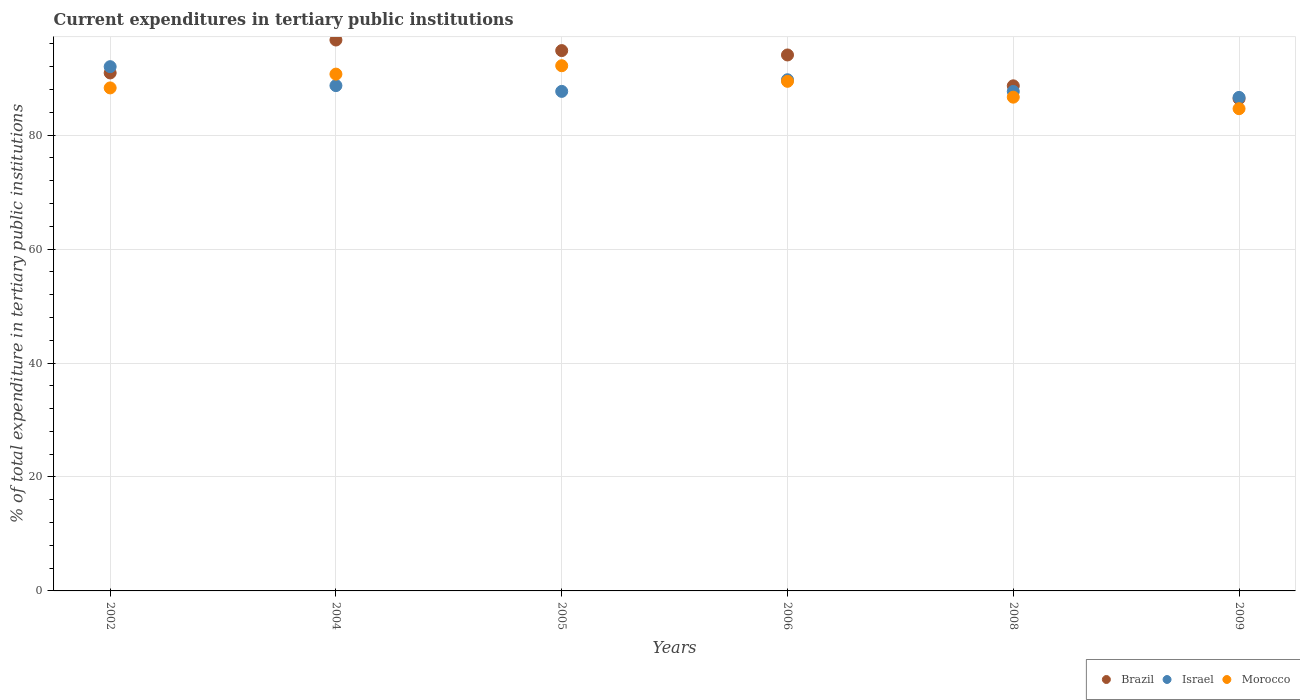How many different coloured dotlines are there?
Offer a terse response. 3. Is the number of dotlines equal to the number of legend labels?
Your answer should be very brief. Yes. What is the current expenditures in tertiary public institutions in Israel in 2002?
Provide a short and direct response. 92.02. Across all years, what is the maximum current expenditures in tertiary public institutions in Brazil?
Ensure brevity in your answer.  96.7. Across all years, what is the minimum current expenditures in tertiary public institutions in Israel?
Your answer should be compact. 86.62. In which year was the current expenditures in tertiary public institutions in Israel maximum?
Provide a succinct answer. 2002. What is the total current expenditures in tertiary public institutions in Morocco in the graph?
Provide a short and direct response. 531.93. What is the difference between the current expenditures in tertiary public institutions in Brazil in 2002 and that in 2005?
Ensure brevity in your answer.  -3.92. What is the difference between the current expenditures in tertiary public institutions in Israel in 2006 and the current expenditures in tertiary public institutions in Brazil in 2008?
Offer a very short reply. 1.07. What is the average current expenditures in tertiary public institutions in Morocco per year?
Provide a succinct answer. 88.65. In the year 2009, what is the difference between the current expenditures in tertiary public institutions in Israel and current expenditures in tertiary public institutions in Morocco?
Offer a terse response. 1.98. What is the ratio of the current expenditures in tertiary public institutions in Israel in 2005 to that in 2006?
Your answer should be compact. 0.98. Is the current expenditures in tertiary public institutions in Brazil in 2002 less than that in 2004?
Keep it short and to the point. Yes. Is the difference between the current expenditures in tertiary public institutions in Israel in 2004 and 2008 greater than the difference between the current expenditures in tertiary public institutions in Morocco in 2004 and 2008?
Provide a succinct answer. No. What is the difference between the highest and the second highest current expenditures in tertiary public institutions in Israel?
Your answer should be compact. 2.3. What is the difference between the highest and the lowest current expenditures in tertiary public institutions in Brazil?
Keep it short and to the point. 10.31. Is the current expenditures in tertiary public institutions in Morocco strictly greater than the current expenditures in tertiary public institutions in Brazil over the years?
Your response must be concise. No. Is the current expenditures in tertiary public institutions in Israel strictly less than the current expenditures in tertiary public institutions in Brazil over the years?
Ensure brevity in your answer.  No. What is the difference between two consecutive major ticks on the Y-axis?
Offer a terse response. 20. Does the graph contain any zero values?
Keep it short and to the point. No. Does the graph contain grids?
Your answer should be compact. Yes. How many legend labels are there?
Your answer should be compact. 3. What is the title of the graph?
Make the answer very short. Current expenditures in tertiary public institutions. What is the label or title of the Y-axis?
Your answer should be compact. % of total expenditure in tertiary public institutions. What is the % of total expenditure in tertiary public institutions in Brazil in 2002?
Your answer should be very brief. 90.92. What is the % of total expenditure in tertiary public institutions in Israel in 2002?
Give a very brief answer. 92.02. What is the % of total expenditure in tertiary public institutions in Morocco in 2002?
Give a very brief answer. 88.29. What is the % of total expenditure in tertiary public institutions in Brazil in 2004?
Your answer should be very brief. 96.7. What is the % of total expenditure in tertiary public institutions of Israel in 2004?
Your answer should be compact. 88.69. What is the % of total expenditure in tertiary public institutions in Morocco in 2004?
Give a very brief answer. 90.71. What is the % of total expenditure in tertiary public institutions in Brazil in 2005?
Keep it short and to the point. 94.84. What is the % of total expenditure in tertiary public institutions of Israel in 2005?
Offer a terse response. 87.68. What is the % of total expenditure in tertiary public institutions in Morocco in 2005?
Make the answer very short. 92.18. What is the % of total expenditure in tertiary public institutions in Brazil in 2006?
Offer a very short reply. 94.07. What is the % of total expenditure in tertiary public institutions in Israel in 2006?
Provide a succinct answer. 89.72. What is the % of total expenditure in tertiary public institutions of Morocco in 2006?
Provide a succinct answer. 89.45. What is the % of total expenditure in tertiary public institutions of Brazil in 2008?
Offer a very short reply. 88.65. What is the % of total expenditure in tertiary public institutions of Israel in 2008?
Offer a terse response. 87.67. What is the % of total expenditure in tertiary public institutions in Morocco in 2008?
Your answer should be compact. 86.66. What is the % of total expenditure in tertiary public institutions in Brazil in 2009?
Provide a short and direct response. 86.39. What is the % of total expenditure in tertiary public institutions in Israel in 2009?
Give a very brief answer. 86.62. What is the % of total expenditure in tertiary public institutions of Morocco in 2009?
Make the answer very short. 84.64. Across all years, what is the maximum % of total expenditure in tertiary public institutions in Brazil?
Provide a short and direct response. 96.7. Across all years, what is the maximum % of total expenditure in tertiary public institutions of Israel?
Your answer should be compact. 92.02. Across all years, what is the maximum % of total expenditure in tertiary public institutions in Morocco?
Ensure brevity in your answer.  92.18. Across all years, what is the minimum % of total expenditure in tertiary public institutions of Brazil?
Your answer should be very brief. 86.39. Across all years, what is the minimum % of total expenditure in tertiary public institutions of Israel?
Give a very brief answer. 86.62. Across all years, what is the minimum % of total expenditure in tertiary public institutions of Morocco?
Your answer should be very brief. 84.64. What is the total % of total expenditure in tertiary public institutions of Brazil in the graph?
Offer a terse response. 551.57. What is the total % of total expenditure in tertiary public institutions of Israel in the graph?
Provide a short and direct response. 532.39. What is the total % of total expenditure in tertiary public institutions of Morocco in the graph?
Your answer should be very brief. 531.93. What is the difference between the % of total expenditure in tertiary public institutions of Brazil in 2002 and that in 2004?
Give a very brief answer. -5.78. What is the difference between the % of total expenditure in tertiary public institutions in Israel in 2002 and that in 2004?
Make the answer very short. 3.33. What is the difference between the % of total expenditure in tertiary public institutions in Morocco in 2002 and that in 2004?
Your response must be concise. -2.42. What is the difference between the % of total expenditure in tertiary public institutions in Brazil in 2002 and that in 2005?
Your answer should be very brief. -3.92. What is the difference between the % of total expenditure in tertiary public institutions in Israel in 2002 and that in 2005?
Your answer should be very brief. 4.34. What is the difference between the % of total expenditure in tertiary public institutions of Morocco in 2002 and that in 2005?
Offer a terse response. -3.89. What is the difference between the % of total expenditure in tertiary public institutions of Brazil in 2002 and that in 2006?
Your answer should be very brief. -3.16. What is the difference between the % of total expenditure in tertiary public institutions of Israel in 2002 and that in 2006?
Offer a terse response. 2.3. What is the difference between the % of total expenditure in tertiary public institutions in Morocco in 2002 and that in 2006?
Give a very brief answer. -1.16. What is the difference between the % of total expenditure in tertiary public institutions in Brazil in 2002 and that in 2008?
Make the answer very short. 2.26. What is the difference between the % of total expenditure in tertiary public institutions in Israel in 2002 and that in 2008?
Provide a short and direct response. 4.35. What is the difference between the % of total expenditure in tertiary public institutions of Morocco in 2002 and that in 2008?
Your answer should be very brief. 1.63. What is the difference between the % of total expenditure in tertiary public institutions of Brazil in 2002 and that in 2009?
Your answer should be very brief. 4.53. What is the difference between the % of total expenditure in tertiary public institutions in Israel in 2002 and that in 2009?
Your answer should be very brief. 5.39. What is the difference between the % of total expenditure in tertiary public institutions in Morocco in 2002 and that in 2009?
Give a very brief answer. 3.65. What is the difference between the % of total expenditure in tertiary public institutions in Brazil in 2004 and that in 2005?
Your answer should be very brief. 1.86. What is the difference between the % of total expenditure in tertiary public institutions in Israel in 2004 and that in 2005?
Offer a terse response. 1.01. What is the difference between the % of total expenditure in tertiary public institutions of Morocco in 2004 and that in 2005?
Offer a terse response. -1.47. What is the difference between the % of total expenditure in tertiary public institutions of Brazil in 2004 and that in 2006?
Offer a terse response. 2.63. What is the difference between the % of total expenditure in tertiary public institutions in Israel in 2004 and that in 2006?
Your answer should be very brief. -1.03. What is the difference between the % of total expenditure in tertiary public institutions of Morocco in 2004 and that in 2006?
Ensure brevity in your answer.  1.26. What is the difference between the % of total expenditure in tertiary public institutions of Brazil in 2004 and that in 2008?
Offer a very short reply. 8.04. What is the difference between the % of total expenditure in tertiary public institutions in Israel in 2004 and that in 2008?
Make the answer very short. 1.02. What is the difference between the % of total expenditure in tertiary public institutions of Morocco in 2004 and that in 2008?
Give a very brief answer. 4.05. What is the difference between the % of total expenditure in tertiary public institutions in Brazil in 2004 and that in 2009?
Offer a very short reply. 10.31. What is the difference between the % of total expenditure in tertiary public institutions in Israel in 2004 and that in 2009?
Your response must be concise. 2.07. What is the difference between the % of total expenditure in tertiary public institutions in Morocco in 2004 and that in 2009?
Keep it short and to the point. 6.07. What is the difference between the % of total expenditure in tertiary public institutions in Brazil in 2005 and that in 2006?
Provide a short and direct response. 0.77. What is the difference between the % of total expenditure in tertiary public institutions of Israel in 2005 and that in 2006?
Offer a terse response. -2.04. What is the difference between the % of total expenditure in tertiary public institutions in Morocco in 2005 and that in 2006?
Your answer should be compact. 2.74. What is the difference between the % of total expenditure in tertiary public institutions in Brazil in 2005 and that in 2008?
Provide a succinct answer. 6.18. What is the difference between the % of total expenditure in tertiary public institutions of Israel in 2005 and that in 2008?
Keep it short and to the point. 0.01. What is the difference between the % of total expenditure in tertiary public institutions in Morocco in 2005 and that in 2008?
Provide a short and direct response. 5.52. What is the difference between the % of total expenditure in tertiary public institutions of Brazil in 2005 and that in 2009?
Provide a succinct answer. 8.45. What is the difference between the % of total expenditure in tertiary public institutions in Israel in 2005 and that in 2009?
Offer a very short reply. 1.06. What is the difference between the % of total expenditure in tertiary public institutions of Morocco in 2005 and that in 2009?
Offer a terse response. 7.54. What is the difference between the % of total expenditure in tertiary public institutions in Brazil in 2006 and that in 2008?
Give a very brief answer. 5.42. What is the difference between the % of total expenditure in tertiary public institutions in Israel in 2006 and that in 2008?
Provide a short and direct response. 2.05. What is the difference between the % of total expenditure in tertiary public institutions of Morocco in 2006 and that in 2008?
Your answer should be compact. 2.78. What is the difference between the % of total expenditure in tertiary public institutions of Brazil in 2006 and that in 2009?
Give a very brief answer. 7.68. What is the difference between the % of total expenditure in tertiary public institutions in Israel in 2006 and that in 2009?
Your answer should be very brief. 3.1. What is the difference between the % of total expenditure in tertiary public institutions in Morocco in 2006 and that in 2009?
Ensure brevity in your answer.  4.81. What is the difference between the % of total expenditure in tertiary public institutions of Brazil in 2008 and that in 2009?
Offer a very short reply. 2.27. What is the difference between the % of total expenditure in tertiary public institutions in Israel in 2008 and that in 2009?
Provide a succinct answer. 1.04. What is the difference between the % of total expenditure in tertiary public institutions in Morocco in 2008 and that in 2009?
Ensure brevity in your answer.  2.02. What is the difference between the % of total expenditure in tertiary public institutions of Brazil in 2002 and the % of total expenditure in tertiary public institutions of Israel in 2004?
Give a very brief answer. 2.23. What is the difference between the % of total expenditure in tertiary public institutions in Brazil in 2002 and the % of total expenditure in tertiary public institutions in Morocco in 2004?
Keep it short and to the point. 0.21. What is the difference between the % of total expenditure in tertiary public institutions of Israel in 2002 and the % of total expenditure in tertiary public institutions of Morocco in 2004?
Provide a succinct answer. 1.31. What is the difference between the % of total expenditure in tertiary public institutions in Brazil in 2002 and the % of total expenditure in tertiary public institutions in Israel in 2005?
Offer a very short reply. 3.24. What is the difference between the % of total expenditure in tertiary public institutions in Brazil in 2002 and the % of total expenditure in tertiary public institutions in Morocco in 2005?
Your response must be concise. -1.27. What is the difference between the % of total expenditure in tertiary public institutions in Israel in 2002 and the % of total expenditure in tertiary public institutions in Morocco in 2005?
Keep it short and to the point. -0.17. What is the difference between the % of total expenditure in tertiary public institutions of Brazil in 2002 and the % of total expenditure in tertiary public institutions of Israel in 2006?
Make the answer very short. 1.2. What is the difference between the % of total expenditure in tertiary public institutions of Brazil in 2002 and the % of total expenditure in tertiary public institutions of Morocco in 2006?
Offer a very short reply. 1.47. What is the difference between the % of total expenditure in tertiary public institutions of Israel in 2002 and the % of total expenditure in tertiary public institutions of Morocco in 2006?
Your answer should be very brief. 2.57. What is the difference between the % of total expenditure in tertiary public institutions in Brazil in 2002 and the % of total expenditure in tertiary public institutions in Israel in 2008?
Ensure brevity in your answer.  3.25. What is the difference between the % of total expenditure in tertiary public institutions of Brazil in 2002 and the % of total expenditure in tertiary public institutions of Morocco in 2008?
Your answer should be compact. 4.25. What is the difference between the % of total expenditure in tertiary public institutions in Israel in 2002 and the % of total expenditure in tertiary public institutions in Morocco in 2008?
Your answer should be very brief. 5.35. What is the difference between the % of total expenditure in tertiary public institutions of Brazil in 2002 and the % of total expenditure in tertiary public institutions of Israel in 2009?
Ensure brevity in your answer.  4.29. What is the difference between the % of total expenditure in tertiary public institutions in Brazil in 2002 and the % of total expenditure in tertiary public institutions in Morocco in 2009?
Your answer should be compact. 6.28. What is the difference between the % of total expenditure in tertiary public institutions of Israel in 2002 and the % of total expenditure in tertiary public institutions of Morocco in 2009?
Your answer should be very brief. 7.38. What is the difference between the % of total expenditure in tertiary public institutions of Brazil in 2004 and the % of total expenditure in tertiary public institutions of Israel in 2005?
Keep it short and to the point. 9.02. What is the difference between the % of total expenditure in tertiary public institutions of Brazil in 2004 and the % of total expenditure in tertiary public institutions of Morocco in 2005?
Your answer should be very brief. 4.51. What is the difference between the % of total expenditure in tertiary public institutions in Israel in 2004 and the % of total expenditure in tertiary public institutions in Morocco in 2005?
Make the answer very short. -3.49. What is the difference between the % of total expenditure in tertiary public institutions in Brazil in 2004 and the % of total expenditure in tertiary public institutions in Israel in 2006?
Provide a succinct answer. 6.98. What is the difference between the % of total expenditure in tertiary public institutions of Brazil in 2004 and the % of total expenditure in tertiary public institutions of Morocco in 2006?
Offer a terse response. 7.25. What is the difference between the % of total expenditure in tertiary public institutions in Israel in 2004 and the % of total expenditure in tertiary public institutions in Morocco in 2006?
Make the answer very short. -0.75. What is the difference between the % of total expenditure in tertiary public institutions in Brazil in 2004 and the % of total expenditure in tertiary public institutions in Israel in 2008?
Provide a short and direct response. 9.03. What is the difference between the % of total expenditure in tertiary public institutions in Brazil in 2004 and the % of total expenditure in tertiary public institutions in Morocco in 2008?
Provide a succinct answer. 10.03. What is the difference between the % of total expenditure in tertiary public institutions of Israel in 2004 and the % of total expenditure in tertiary public institutions of Morocco in 2008?
Your answer should be very brief. 2.03. What is the difference between the % of total expenditure in tertiary public institutions in Brazil in 2004 and the % of total expenditure in tertiary public institutions in Israel in 2009?
Offer a very short reply. 10.07. What is the difference between the % of total expenditure in tertiary public institutions in Brazil in 2004 and the % of total expenditure in tertiary public institutions in Morocco in 2009?
Offer a very short reply. 12.06. What is the difference between the % of total expenditure in tertiary public institutions of Israel in 2004 and the % of total expenditure in tertiary public institutions of Morocco in 2009?
Offer a very short reply. 4.05. What is the difference between the % of total expenditure in tertiary public institutions of Brazil in 2005 and the % of total expenditure in tertiary public institutions of Israel in 2006?
Make the answer very short. 5.12. What is the difference between the % of total expenditure in tertiary public institutions in Brazil in 2005 and the % of total expenditure in tertiary public institutions in Morocco in 2006?
Make the answer very short. 5.39. What is the difference between the % of total expenditure in tertiary public institutions in Israel in 2005 and the % of total expenditure in tertiary public institutions in Morocco in 2006?
Make the answer very short. -1.77. What is the difference between the % of total expenditure in tertiary public institutions in Brazil in 2005 and the % of total expenditure in tertiary public institutions in Israel in 2008?
Provide a short and direct response. 7.17. What is the difference between the % of total expenditure in tertiary public institutions of Brazil in 2005 and the % of total expenditure in tertiary public institutions of Morocco in 2008?
Provide a succinct answer. 8.18. What is the difference between the % of total expenditure in tertiary public institutions of Israel in 2005 and the % of total expenditure in tertiary public institutions of Morocco in 2008?
Provide a succinct answer. 1.02. What is the difference between the % of total expenditure in tertiary public institutions in Brazil in 2005 and the % of total expenditure in tertiary public institutions in Israel in 2009?
Provide a short and direct response. 8.22. What is the difference between the % of total expenditure in tertiary public institutions of Brazil in 2005 and the % of total expenditure in tertiary public institutions of Morocco in 2009?
Keep it short and to the point. 10.2. What is the difference between the % of total expenditure in tertiary public institutions of Israel in 2005 and the % of total expenditure in tertiary public institutions of Morocco in 2009?
Make the answer very short. 3.04. What is the difference between the % of total expenditure in tertiary public institutions of Brazil in 2006 and the % of total expenditure in tertiary public institutions of Israel in 2008?
Your response must be concise. 6.4. What is the difference between the % of total expenditure in tertiary public institutions in Brazil in 2006 and the % of total expenditure in tertiary public institutions in Morocco in 2008?
Your answer should be compact. 7.41. What is the difference between the % of total expenditure in tertiary public institutions of Israel in 2006 and the % of total expenditure in tertiary public institutions of Morocco in 2008?
Offer a terse response. 3.06. What is the difference between the % of total expenditure in tertiary public institutions in Brazil in 2006 and the % of total expenditure in tertiary public institutions in Israel in 2009?
Ensure brevity in your answer.  7.45. What is the difference between the % of total expenditure in tertiary public institutions in Brazil in 2006 and the % of total expenditure in tertiary public institutions in Morocco in 2009?
Give a very brief answer. 9.43. What is the difference between the % of total expenditure in tertiary public institutions in Israel in 2006 and the % of total expenditure in tertiary public institutions in Morocco in 2009?
Your answer should be very brief. 5.08. What is the difference between the % of total expenditure in tertiary public institutions in Brazil in 2008 and the % of total expenditure in tertiary public institutions in Israel in 2009?
Your answer should be very brief. 2.03. What is the difference between the % of total expenditure in tertiary public institutions in Brazil in 2008 and the % of total expenditure in tertiary public institutions in Morocco in 2009?
Offer a very short reply. 4.01. What is the difference between the % of total expenditure in tertiary public institutions of Israel in 2008 and the % of total expenditure in tertiary public institutions of Morocco in 2009?
Your response must be concise. 3.03. What is the average % of total expenditure in tertiary public institutions in Brazil per year?
Give a very brief answer. 91.93. What is the average % of total expenditure in tertiary public institutions in Israel per year?
Ensure brevity in your answer.  88.73. What is the average % of total expenditure in tertiary public institutions of Morocco per year?
Ensure brevity in your answer.  88.65. In the year 2002, what is the difference between the % of total expenditure in tertiary public institutions in Brazil and % of total expenditure in tertiary public institutions in Israel?
Your answer should be very brief. -1.1. In the year 2002, what is the difference between the % of total expenditure in tertiary public institutions in Brazil and % of total expenditure in tertiary public institutions in Morocco?
Your answer should be very brief. 2.63. In the year 2002, what is the difference between the % of total expenditure in tertiary public institutions in Israel and % of total expenditure in tertiary public institutions in Morocco?
Your answer should be compact. 3.73. In the year 2004, what is the difference between the % of total expenditure in tertiary public institutions in Brazil and % of total expenditure in tertiary public institutions in Israel?
Ensure brevity in your answer.  8.01. In the year 2004, what is the difference between the % of total expenditure in tertiary public institutions of Brazil and % of total expenditure in tertiary public institutions of Morocco?
Make the answer very short. 5.99. In the year 2004, what is the difference between the % of total expenditure in tertiary public institutions in Israel and % of total expenditure in tertiary public institutions in Morocco?
Ensure brevity in your answer.  -2.02. In the year 2005, what is the difference between the % of total expenditure in tertiary public institutions of Brazil and % of total expenditure in tertiary public institutions of Israel?
Provide a succinct answer. 7.16. In the year 2005, what is the difference between the % of total expenditure in tertiary public institutions of Brazil and % of total expenditure in tertiary public institutions of Morocco?
Offer a very short reply. 2.66. In the year 2005, what is the difference between the % of total expenditure in tertiary public institutions of Israel and % of total expenditure in tertiary public institutions of Morocco?
Offer a terse response. -4.5. In the year 2006, what is the difference between the % of total expenditure in tertiary public institutions in Brazil and % of total expenditure in tertiary public institutions in Israel?
Offer a very short reply. 4.35. In the year 2006, what is the difference between the % of total expenditure in tertiary public institutions in Brazil and % of total expenditure in tertiary public institutions in Morocco?
Offer a very short reply. 4.63. In the year 2006, what is the difference between the % of total expenditure in tertiary public institutions of Israel and % of total expenditure in tertiary public institutions of Morocco?
Your response must be concise. 0.27. In the year 2008, what is the difference between the % of total expenditure in tertiary public institutions of Brazil and % of total expenditure in tertiary public institutions of Israel?
Your response must be concise. 0.99. In the year 2008, what is the difference between the % of total expenditure in tertiary public institutions in Brazil and % of total expenditure in tertiary public institutions in Morocco?
Your response must be concise. 1.99. In the year 2008, what is the difference between the % of total expenditure in tertiary public institutions in Israel and % of total expenditure in tertiary public institutions in Morocco?
Give a very brief answer. 1. In the year 2009, what is the difference between the % of total expenditure in tertiary public institutions of Brazil and % of total expenditure in tertiary public institutions of Israel?
Offer a very short reply. -0.23. In the year 2009, what is the difference between the % of total expenditure in tertiary public institutions in Brazil and % of total expenditure in tertiary public institutions in Morocco?
Give a very brief answer. 1.75. In the year 2009, what is the difference between the % of total expenditure in tertiary public institutions in Israel and % of total expenditure in tertiary public institutions in Morocco?
Offer a terse response. 1.98. What is the ratio of the % of total expenditure in tertiary public institutions in Brazil in 2002 to that in 2004?
Offer a very short reply. 0.94. What is the ratio of the % of total expenditure in tertiary public institutions of Israel in 2002 to that in 2004?
Ensure brevity in your answer.  1.04. What is the ratio of the % of total expenditure in tertiary public institutions of Morocco in 2002 to that in 2004?
Give a very brief answer. 0.97. What is the ratio of the % of total expenditure in tertiary public institutions in Brazil in 2002 to that in 2005?
Provide a short and direct response. 0.96. What is the ratio of the % of total expenditure in tertiary public institutions in Israel in 2002 to that in 2005?
Provide a short and direct response. 1.05. What is the ratio of the % of total expenditure in tertiary public institutions of Morocco in 2002 to that in 2005?
Keep it short and to the point. 0.96. What is the ratio of the % of total expenditure in tertiary public institutions in Brazil in 2002 to that in 2006?
Offer a very short reply. 0.97. What is the ratio of the % of total expenditure in tertiary public institutions in Israel in 2002 to that in 2006?
Make the answer very short. 1.03. What is the ratio of the % of total expenditure in tertiary public institutions of Morocco in 2002 to that in 2006?
Your answer should be very brief. 0.99. What is the ratio of the % of total expenditure in tertiary public institutions of Brazil in 2002 to that in 2008?
Your answer should be very brief. 1.03. What is the ratio of the % of total expenditure in tertiary public institutions of Israel in 2002 to that in 2008?
Provide a short and direct response. 1.05. What is the ratio of the % of total expenditure in tertiary public institutions of Morocco in 2002 to that in 2008?
Your response must be concise. 1.02. What is the ratio of the % of total expenditure in tertiary public institutions in Brazil in 2002 to that in 2009?
Make the answer very short. 1.05. What is the ratio of the % of total expenditure in tertiary public institutions of Israel in 2002 to that in 2009?
Your answer should be compact. 1.06. What is the ratio of the % of total expenditure in tertiary public institutions in Morocco in 2002 to that in 2009?
Your response must be concise. 1.04. What is the ratio of the % of total expenditure in tertiary public institutions of Brazil in 2004 to that in 2005?
Ensure brevity in your answer.  1.02. What is the ratio of the % of total expenditure in tertiary public institutions in Israel in 2004 to that in 2005?
Your answer should be very brief. 1.01. What is the ratio of the % of total expenditure in tertiary public institutions in Morocco in 2004 to that in 2005?
Give a very brief answer. 0.98. What is the ratio of the % of total expenditure in tertiary public institutions of Brazil in 2004 to that in 2006?
Your answer should be very brief. 1.03. What is the ratio of the % of total expenditure in tertiary public institutions of Israel in 2004 to that in 2006?
Your response must be concise. 0.99. What is the ratio of the % of total expenditure in tertiary public institutions in Morocco in 2004 to that in 2006?
Your answer should be very brief. 1.01. What is the ratio of the % of total expenditure in tertiary public institutions in Brazil in 2004 to that in 2008?
Offer a very short reply. 1.09. What is the ratio of the % of total expenditure in tertiary public institutions in Israel in 2004 to that in 2008?
Provide a short and direct response. 1.01. What is the ratio of the % of total expenditure in tertiary public institutions in Morocco in 2004 to that in 2008?
Provide a succinct answer. 1.05. What is the ratio of the % of total expenditure in tertiary public institutions of Brazil in 2004 to that in 2009?
Give a very brief answer. 1.12. What is the ratio of the % of total expenditure in tertiary public institutions of Israel in 2004 to that in 2009?
Offer a terse response. 1.02. What is the ratio of the % of total expenditure in tertiary public institutions of Morocco in 2004 to that in 2009?
Offer a terse response. 1.07. What is the ratio of the % of total expenditure in tertiary public institutions in Brazil in 2005 to that in 2006?
Your response must be concise. 1.01. What is the ratio of the % of total expenditure in tertiary public institutions in Israel in 2005 to that in 2006?
Your answer should be compact. 0.98. What is the ratio of the % of total expenditure in tertiary public institutions in Morocco in 2005 to that in 2006?
Provide a short and direct response. 1.03. What is the ratio of the % of total expenditure in tertiary public institutions of Brazil in 2005 to that in 2008?
Provide a succinct answer. 1.07. What is the ratio of the % of total expenditure in tertiary public institutions of Israel in 2005 to that in 2008?
Offer a terse response. 1. What is the ratio of the % of total expenditure in tertiary public institutions in Morocco in 2005 to that in 2008?
Provide a short and direct response. 1.06. What is the ratio of the % of total expenditure in tertiary public institutions in Brazil in 2005 to that in 2009?
Your answer should be compact. 1.1. What is the ratio of the % of total expenditure in tertiary public institutions in Israel in 2005 to that in 2009?
Your answer should be compact. 1.01. What is the ratio of the % of total expenditure in tertiary public institutions in Morocco in 2005 to that in 2009?
Your response must be concise. 1.09. What is the ratio of the % of total expenditure in tertiary public institutions in Brazil in 2006 to that in 2008?
Offer a terse response. 1.06. What is the ratio of the % of total expenditure in tertiary public institutions of Israel in 2006 to that in 2008?
Offer a terse response. 1.02. What is the ratio of the % of total expenditure in tertiary public institutions in Morocco in 2006 to that in 2008?
Make the answer very short. 1.03. What is the ratio of the % of total expenditure in tertiary public institutions of Brazil in 2006 to that in 2009?
Offer a very short reply. 1.09. What is the ratio of the % of total expenditure in tertiary public institutions of Israel in 2006 to that in 2009?
Make the answer very short. 1.04. What is the ratio of the % of total expenditure in tertiary public institutions of Morocco in 2006 to that in 2009?
Keep it short and to the point. 1.06. What is the ratio of the % of total expenditure in tertiary public institutions in Brazil in 2008 to that in 2009?
Your response must be concise. 1.03. What is the ratio of the % of total expenditure in tertiary public institutions of Israel in 2008 to that in 2009?
Ensure brevity in your answer.  1.01. What is the ratio of the % of total expenditure in tertiary public institutions in Morocco in 2008 to that in 2009?
Provide a short and direct response. 1.02. What is the difference between the highest and the second highest % of total expenditure in tertiary public institutions of Brazil?
Offer a very short reply. 1.86. What is the difference between the highest and the second highest % of total expenditure in tertiary public institutions in Israel?
Your answer should be very brief. 2.3. What is the difference between the highest and the second highest % of total expenditure in tertiary public institutions of Morocco?
Offer a terse response. 1.47. What is the difference between the highest and the lowest % of total expenditure in tertiary public institutions of Brazil?
Give a very brief answer. 10.31. What is the difference between the highest and the lowest % of total expenditure in tertiary public institutions in Israel?
Ensure brevity in your answer.  5.39. What is the difference between the highest and the lowest % of total expenditure in tertiary public institutions in Morocco?
Give a very brief answer. 7.54. 